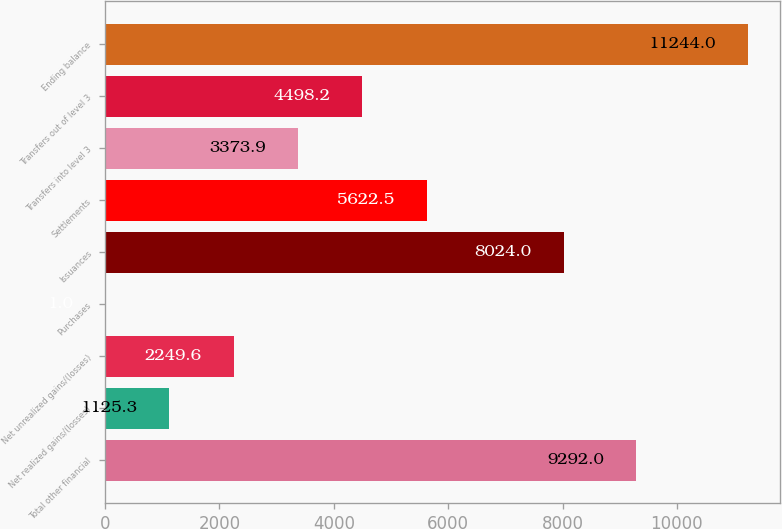Convert chart to OTSL. <chart><loc_0><loc_0><loc_500><loc_500><bar_chart><fcel>Total other financial<fcel>Net realized gains/(losses)<fcel>Net unrealized gains/(losses)<fcel>Purchases<fcel>Issuances<fcel>Settlements<fcel>Transfers into level 3<fcel>Transfers out of level 3<fcel>Ending balance<nl><fcel>9292<fcel>1125.3<fcel>2249.6<fcel>1<fcel>8024<fcel>5622.5<fcel>3373.9<fcel>4498.2<fcel>11244<nl></chart> 